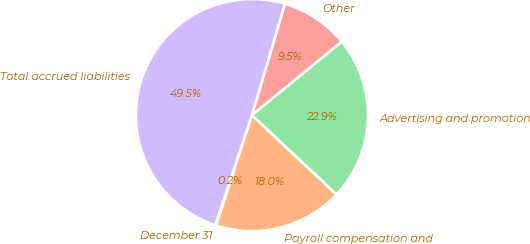Convert chart. <chart><loc_0><loc_0><loc_500><loc_500><pie_chart><fcel>December 31<fcel>Payroll compensation and<fcel>Advertising and promotion<fcel>Other<fcel>Total accrued liabilities<nl><fcel>0.15%<fcel>17.98%<fcel>22.91%<fcel>9.5%<fcel>49.46%<nl></chart> 